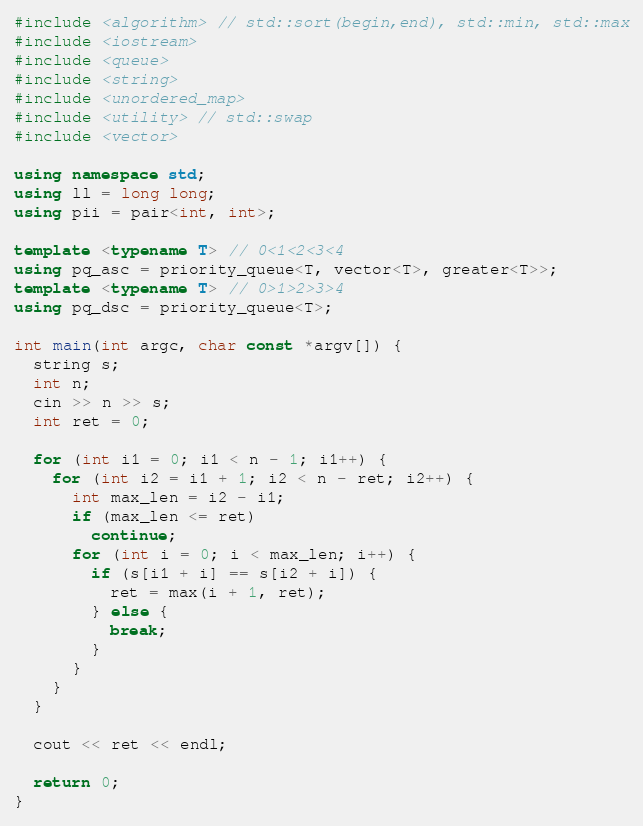<code> <loc_0><loc_0><loc_500><loc_500><_C++_>#include <algorithm> // std::sort(begin,end), std::min, std::max
#include <iostream>
#include <queue>
#include <string>
#include <unordered_map>
#include <utility> // std::swap
#include <vector>

using namespace std;
using ll = long long;
using pii = pair<int, int>;

template <typename T> // 0<1<2<3<4
using pq_asc = priority_queue<T, vector<T>, greater<T>>;
template <typename T> // 0>1>2>3>4
using pq_dsc = priority_queue<T>;

int main(int argc, char const *argv[]) {
  string s;
  int n;
  cin >> n >> s;
  int ret = 0;

  for (int i1 = 0; i1 < n - 1; i1++) {
    for (int i2 = i1 + 1; i2 < n - ret; i2++) {
      int max_len = i2 - i1;
      if (max_len <= ret)
        continue;
      for (int i = 0; i < max_len; i++) {
        if (s[i1 + i] == s[i2 + i]) {
          ret = max(i + 1, ret);
        } else {
          break;
        }
      }
    }
  }

  cout << ret << endl;
  
  return 0;
}
</code> 